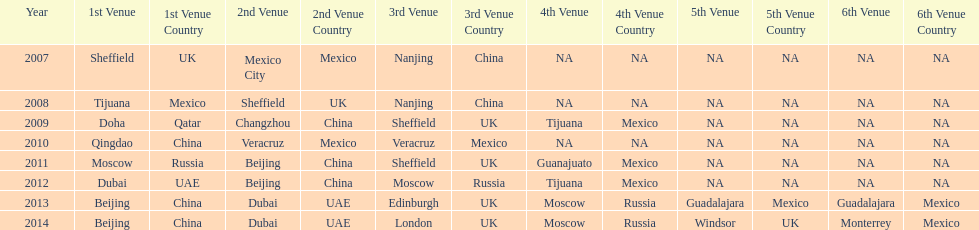Which year is previous to 2011 2010. 